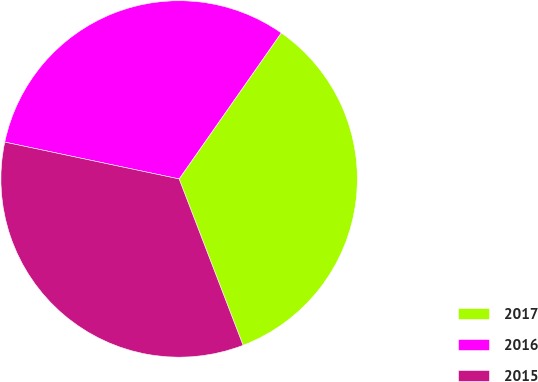Convert chart. <chart><loc_0><loc_0><loc_500><loc_500><pie_chart><fcel>2017<fcel>2016<fcel>2015<nl><fcel>34.45%<fcel>31.4%<fcel>34.16%<nl></chart> 